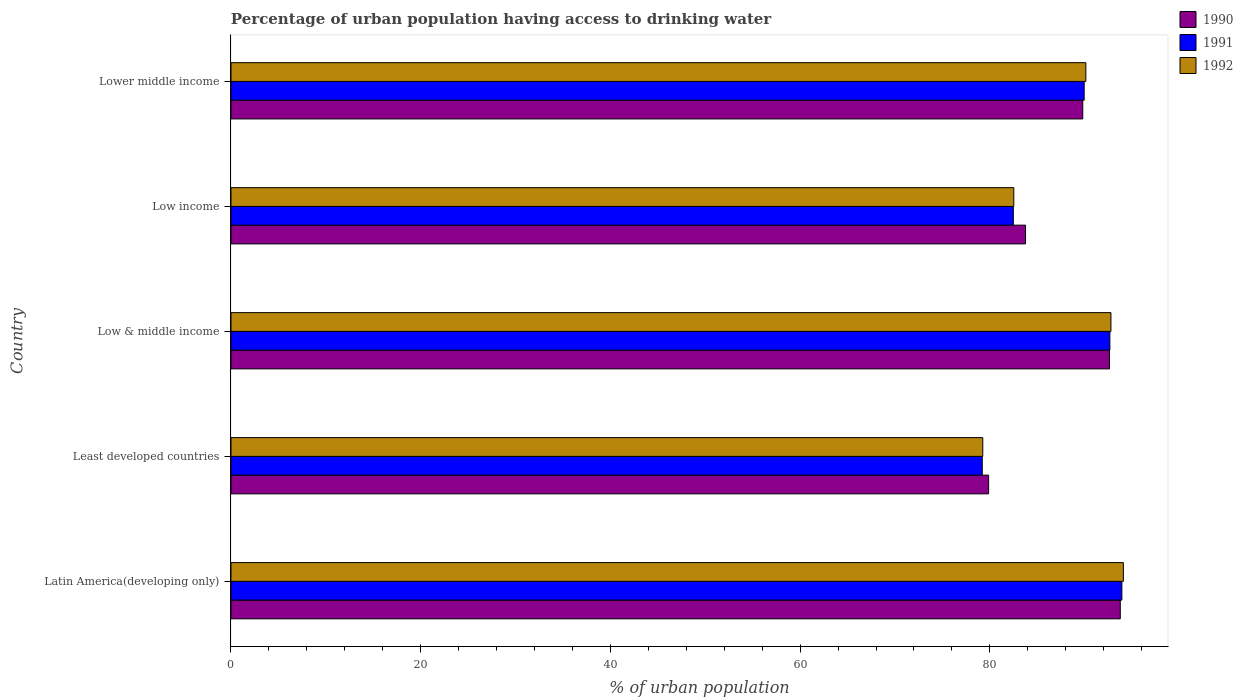How many different coloured bars are there?
Keep it short and to the point. 3. Are the number of bars per tick equal to the number of legend labels?
Ensure brevity in your answer.  Yes. What is the label of the 1st group of bars from the top?
Give a very brief answer. Lower middle income. What is the percentage of urban population having access to drinking water in 1992 in Low & middle income?
Make the answer very short. 92.76. Across all countries, what is the maximum percentage of urban population having access to drinking water in 1990?
Give a very brief answer. 93.75. Across all countries, what is the minimum percentage of urban population having access to drinking water in 1991?
Your answer should be very brief. 79.2. In which country was the percentage of urban population having access to drinking water in 1991 maximum?
Your answer should be compact. Latin America(developing only). In which country was the percentage of urban population having access to drinking water in 1991 minimum?
Make the answer very short. Least developed countries. What is the total percentage of urban population having access to drinking water in 1992 in the graph?
Keep it short and to the point. 438.73. What is the difference between the percentage of urban population having access to drinking water in 1990 in Latin America(developing only) and that in Low income?
Give a very brief answer. 9.99. What is the difference between the percentage of urban population having access to drinking water in 1991 in Latin America(developing only) and the percentage of urban population having access to drinking water in 1990 in Least developed countries?
Keep it short and to the point. 14.05. What is the average percentage of urban population having access to drinking water in 1991 per country?
Your response must be concise. 87.64. What is the difference between the percentage of urban population having access to drinking water in 1992 and percentage of urban population having access to drinking water in 1990 in Least developed countries?
Provide a short and direct response. -0.62. What is the ratio of the percentage of urban population having access to drinking water in 1991 in Latin America(developing only) to that in Low & middle income?
Provide a short and direct response. 1.01. Is the percentage of urban population having access to drinking water in 1991 in Least developed countries less than that in Low & middle income?
Provide a short and direct response. Yes. Is the difference between the percentage of urban population having access to drinking water in 1992 in Low income and Lower middle income greater than the difference between the percentage of urban population having access to drinking water in 1990 in Low income and Lower middle income?
Your response must be concise. No. What is the difference between the highest and the second highest percentage of urban population having access to drinking water in 1992?
Your answer should be compact. 1.31. What is the difference between the highest and the lowest percentage of urban population having access to drinking water in 1991?
Ensure brevity in your answer.  14.72. In how many countries, is the percentage of urban population having access to drinking water in 1991 greater than the average percentage of urban population having access to drinking water in 1991 taken over all countries?
Provide a short and direct response. 3. Is the sum of the percentage of urban population having access to drinking water in 1991 in Least developed countries and Low income greater than the maximum percentage of urban population having access to drinking water in 1992 across all countries?
Keep it short and to the point. Yes. Is it the case that in every country, the sum of the percentage of urban population having access to drinking water in 1991 and percentage of urban population having access to drinking water in 1992 is greater than the percentage of urban population having access to drinking water in 1990?
Your response must be concise. Yes. Are all the bars in the graph horizontal?
Your response must be concise. Yes. How many countries are there in the graph?
Make the answer very short. 5. What is the difference between two consecutive major ticks on the X-axis?
Provide a succinct answer. 20. Does the graph contain any zero values?
Your answer should be very brief. No. Does the graph contain grids?
Keep it short and to the point. No. What is the title of the graph?
Your response must be concise. Percentage of urban population having access to drinking water. Does "2010" appear as one of the legend labels in the graph?
Give a very brief answer. No. What is the label or title of the X-axis?
Keep it short and to the point. % of urban population. What is the label or title of the Y-axis?
Offer a terse response. Country. What is the % of urban population in 1990 in Latin America(developing only)?
Give a very brief answer. 93.75. What is the % of urban population in 1991 in Latin America(developing only)?
Provide a succinct answer. 93.92. What is the % of urban population in 1992 in Latin America(developing only)?
Your response must be concise. 94.07. What is the % of urban population of 1990 in Least developed countries?
Your answer should be compact. 79.87. What is the % of urban population of 1991 in Least developed countries?
Keep it short and to the point. 79.2. What is the % of urban population in 1992 in Least developed countries?
Your response must be concise. 79.25. What is the % of urban population of 1990 in Low & middle income?
Your answer should be compact. 92.61. What is the % of urban population in 1991 in Low & middle income?
Your answer should be very brief. 92.65. What is the % of urban population of 1992 in Low & middle income?
Give a very brief answer. 92.76. What is the % of urban population in 1990 in Low income?
Make the answer very short. 83.76. What is the % of urban population of 1991 in Low income?
Keep it short and to the point. 82.47. What is the % of urban population in 1992 in Low income?
Keep it short and to the point. 82.52. What is the % of urban population in 1990 in Lower middle income?
Your answer should be very brief. 89.79. What is the % of urban population of 1991 in Lower middle income?
Provide a short and direct response. 89.94. What is the % of urban population of 1992 in Lower middle income?
Ensure brevity in your answer.  90.12. Across all countries, what is the maximum % of urban population of 1990?
Provide a short and direct response. 93.75. Across all countries, what is the maximum % of urban population in 1991?
Your answer should be compact. 93.92. Across all countries, what is the maximum % of urban population in 1992?
Your response must be concise. 94.07. Across all countries, what is the minimum % of urban population of 1990?
Keep it short and to the point. 79.87. Across all countries, what is the minimum % of urban population in 1991?
Keep it short and to the point. 79.2. Across all countries, what is the minimum % of urban population in 1992?
Offer a terse response. 79.25. What is the total % of urban population in 1990 in the graph?
Provide a short and direct response. 439.78. What is the total % of urban population in 1991 in the graph?
Make the answer very short. 438.18. What is the total % of urban population in 1992 in the graph?
Give a very brief answer. 438.73. What is the difference between the % of urban population of 1990 in Latin America(developing only) and that in Least developed countries?
Your answer should be compact. 13.88. What is the difference between the % of urban population of 1991 in Latin America(developing only) and that in Least developed countries?
Keep it short and to the point. 14.72. What is the difference between the % of urban population of 1992 in Latin America(developing only) and that in Least developed countries?
Provide a short and direct response. 14.82. What is the difference between the % of urban population in 1990 in Latin America(developing only) and that in Low & middle income?
Provide a short and direct response. 1.14. What is the difference between the % of urban population in 1991 in Latin America(developing only) and that in Low & middle income?
Give a very brief answer. 1.27. What is the difference between the % of urban population of 1992 in Latin America(developing only) and that in Low & middle income?
Provide a short and direct response. 1.31. What is the difference between the % of urban population in 1990 in Latin America(developing only) and that in Low income?
Provide a short and direct response. 9.99. What is the difference between the % of urban population in 1991 in Latin America(developing only) and that in Low income?
Provide a short and direct response. 11.44. What is the difference between the % of urban population of 1992 in Latin America(developing only) and that in Low income?
Provide a short and direct response. 11.55. What is the difference between the % of urban population of 1990 in Latin America(developing only) and that in Lower middle income?
Provide a short and direct response. 3.95. What is the difference between the % of urban population of 1991 in Latin America(developing only) and that in Lower middle income?
Offer a very short reply. 3.97. What is the difference between the % of urban population in 1992 in Latin America(developing only) and that in Lower middle income?
Your answer should be compact. 3.96. What is the difference between the % of urban population of 1990 in Least developed countries and that in Low & middle income?
Offer a terse response. -12.74. What is the difference between the % of urban population in 1991 in Least developed countries and that in Low & middle income?
Offer a terse response. -13.45. What is the difference between the % of urban population of 1992 in Least developed countries and that in Low & middle income?
Keep it short and to the point. -13.51. What is the difference between the % of urban population of 1990 in Least developed countries and that in Low income?
Your answer should be very brief. -3.89. What is the difference between the % of urban population in 1991 in Least developed countries and that in Low income?
Your answer should be very brief. -3.28. What is the difference between the % of urban population in 1992 in Least developed countries and that in Low income?
Keep it short and to the point. -3.27. What is the difference between the % of urban population in 1990 in Least developed countries and that in Lower middle income?
Your answer should be very brief. -9.92. What is the difference between the % of urban population in 1991 in Least developed countries and that in Lower middle income?
Ensure brevity in your answer.  -10.74. What is the difference between the % of urban population in 1992 in Least developed countries and that in Lower middle income?
Offer a very short reply. -10.87. What is the difference between the % of urban population in 1990 in Low & middle income and that in Low income?
Provide a succinct answer. 8.85. What is the difference between the % of urban population in 1991 in Low & middle income and that in Low income?
Your answer should be compact. 10.18. What is the difference between the % of urban population of 1992 in Low & middle income and that in Low income?
Ensure brevity in your answer.  10.24. What is the difference between the % of urban population of 1990 in Low & middle income and that in Lower middle income?
Your response must be concise. 2.82. What is the difference between the % of urban population in 1991 in Low & middle income and that in Lower middle income?
Provide a short and direct response. 2.71. What is the difference between the % of urban population in 1992 in Low & middle income and that in Lower middle income?
Your response must be concise. 2.64. What is the difference between the % of urban population in 1990 in Low income and that in Lower middle income?
Your answer should be compact. -6.03. What is the difference between the % of urban population of 1991 in Low income and that in Lower middle income?
Offer a very short reply. -7.47. What is the difference between the % of urban population in 1992 in Low income and that in Lower middle income?
Keep it short and to the point. -7.6. What is the difference between the % of urban population of 1990 in Latin America(developing only) and the % of urban population of 1991 in Least developed countries?
Your answer should be compact. 14.55. What is the difference between the % of urban population in 1990 in Latin America(developing only) and the % of urban population in 1992 in Least developed countries?
Provide a succinct answer. 14.5. What is the difference between the % of urban population in 1991 in Latin America(developing only) and the % of urban population in 1992 in Least developed countries?
Your answer should be very brief. 14.66. What is the difference between the % of urban population in 1990 in Latin America(developing only) and the % of urban population in 1991 in Low & middle income?
Keep it short and to the point. 1.1. What is the difference between the % of urban population of 1990 in Latin America(developing only) and the % of urban population of 1992 in Low & middle income?
Offer a very short reply. 0.99. What is the difference between the % of urban population in 1991 in Latin America(developing only) and the % of urban population in 1992 in Low & middle income?
Ensure brevity in your answer.  1.15. What is the difference between the % of urban population in 1990 in Latin America(developing only) and the % of urban population in 1991 in Low income?
Ensure brevity in your answer.  11.27. What is the difference between the % of urban population in 1990 in Latin America(developing only) and the % of urban population in 1992 in Low income?
Offer a very short reply. 11.23. What is the difference between the % of urban population of 1991 in Latin America(developing only) and the % of urban population of 1992 in Low income?
Provide a succinct answer. 11.39. What is the difference between the % of urban population of 1990 in Latin America(developing only) and the % of urban population of 1991 in Lower middle income?
Give a very brief answer. 3.81. What is the difference between the % of urban population of 1990 in Latin America(developing only) and the % of urban population of 1992 in Lower middle income?
Provide a succinct answer. 3.63. What is the difference between the % of urban population in 1991 in Latin America(developing only) and the % of urban population in 1992 in Lower middle income?
Provide a succinct answer. 3.8. What is the difference between the % of urban population of 1990 in Least developed countries and the % of urban population of 1991 in Low & middle income?
Your response must be concise. -12.78. What is the difference between the % of urban population in 1990 in Least developed countries and the % of urban population in 1992 in Low & middle income?
Give a very brief answer. -12.89. What is the difference between the % of urban population of 1991 in Least developed countries and the % of urban population of 1992 in Low & middle income?
Provide a short and direct response. -13.56. What is the difference between the % of urban population of 1990 in Least developed countries and the % of urban population of 1991 in Low income?
Your response must be concise. -2.6. What is the difference between the % of urban population of 1990 in Least developed countries and the % of urban population of 1992 in Low income?
Your answer should be compact. -2.65. What is the difference between the % of urban population of 1991 in Least developed countries and the % of urban population of 1992 in Low income?
Your answer should be very brief. -3.32. What is the difference between the % of urban population of 1990 in Least developed countries and the % of urban population of 1991 in Lower middle income?
Your response must be concise. -10.07. What is the difference between the % of urban population in 1990 in Least developed countries and the % of urban population in 1992 in Lower middle income?
Give a very brief answer. -10.25. What is the difference between the % of urban population in 1991 in Least developed countries and the % of urban population in 1992 in Lower middle income?
Your response must be concise. -10.92. What is the difference between the % of urban population of 1990 in Low & middle income and the % of urban population of 1991 in Low income?
Your response must be concise. 10.14. What is the difference between the % of urban population of 1990 in Low & middle income and the % of urban population of 1992 in Low income?
Provide a short and direct response. 10.09. What is the difference between the % of urban population in 1991 in Low & middle income and the % of urban population in 1992 in Low income?
Offer a very short reply. 10.13. What is the difference between the % of urban population in 1990 in Low & middle income and the % of urban population in 1991 in Lower middle income?
Your answer should be very brief. 2.67. What is the difference between the % of urban population in 1990 in Low & middle income and the % of urban population in 1992 in Lower middle income?
Offer a terse response. 2.49. What is the difference between the % of urban population in 1991 in Low & middle income and the % of urban population in 1992 in Lower middle income?
Keep it short and to the point. 2.53. What is the difference between the % of urban population of 1990 in Low income and the % of urban population of 1991 in Lower middle income?
Provide a succinct answer. -6.18. What is the difference between the % of urban population in 1990 in Low income and the % of urban population in 1992 in Lower middle income?
Offer a terse response. -6.36. What is the difference between the % of urban population in 1991 in Low income and the % of urban population in 1992 in Lower middle income?
Your answer should be very brief. -7.64. What is the average % of urban population of 1990 per country?
Provide a succinct answer. 87.96. What is the average % of urban population in 1991 per country?
Keep it short and to the point. 87.64. What is the average % of urban population of 1992 per country?
Make the answer very short. 87.75. What is the difference between the % of urban population in 1990 and % of urban population in 1991 in Latin America(developing only)?
Keep it short and to the point. -0.17. What is the difference between the % of urban population of 1990 and % of urban population of 1992 in Latin America(developing only)?
Ensure brevity in your answer.  -0.33. What is the difference between the % of urban population in 1991 and % of urban population in 1992 in Latin America(developing only)?
Ensure brevity in your answer.  -0.16. What is the difference between the % of urban population of 1990 and % of urban population of 1991 in Least developed countries?
Provide a succinct answer. 0.67. What is the difference between the % of urban population of 1990 and % of urban population of 1992 in Least developed countries?
Make the answer very short. 0.62. What is the difference between the % of urban population in 1991 and % of urban population in 1992 in Least developed countries?
Give a very brief answer. -0.05. What is the difference between the % of urban population in 1990 and % of urban population in 1991 in Low & middle income?
Provide a short and direct response. -0.04. What is the difference between the % of urban population in 1990 and % of urban population in 1992 in Low & middle income?
Your answer should be compact. -0.15. What is the difference between the % of urban population of 1991 and % of urban population of 1992 in Low & middle income?
Your answer should be very brief. -0.11. What is the difference between the % of urban population of 1990 and % of urban population of 1991 in Low income?
Your answer should be compact. 1.29. What is the difference between the % of urban population in 1990 and % of urban population in 1992 in Low income?
Ensure brevity in your answer.  1.24. What is the difference between the % of urban population in 1991 and % of urban population in 1992 in Low income?
Your answer should be very brief. -0.05. What is the difference between the % of urban population in 1990 and % of urban population in 1991 in Lower middle income?
Your answer should be very brief. -0.15. What is the difference between the % of urban population of 1990 and % of urban population of 1992 in Lower middle income?
Offer a terse response. -0.33. What is the difference between the % of urban population in 1991 and % of urban population in 1992 in Lower middle income?
Provide a short and direct response. -0.18. What is the ratio of the % of urban population of 1990 in Latin America(developing only) to that in Least developed countries?
Keep it short and to the point. 1.17. What is the ratio of the % of urban population in 1991 in Latin America(developing only) to that in Least developed countries?
Keep it short and to the point. 1.19. What is the ratio of the % of urban population in 1992 in Latin America(developing only) to that in Least developed countries?
Offer a terse response. 1.19. What is the ratio of the % of urban population of 1990 in Latin America(developing only) to that in Low & middle income?
Your answer should be compact. 1.01. What is the ratio of the % of urban population in 1991 in Latin America(developing only) to that in Low & middle income?
Your response must be concise. 1.01. What is the ratio of the % of urban population in 1992 in Latin America(developing only) to that in Low & middle income?
Offer a terse response. 1.01. What is the ratio of the % of urban population of 1990 in Latin America(developing only) to that in Low income?
Provide a succinct answer. 1.12. What is the ratio of the % of urban population of 1991 in Latin America(developing only) to that in Low income?
Offer a terse response. 1.14. What is the ratio of the % of urban population of 1992 in Latin America(developing only) to that in Low income?
Give a very brief answer. 1.14. What is the ratio of the % of urban population of 1990 in Latin America(developing only) to that in Lower middle income?
Offer a terse response. 1.04. What is the ratio of the % of urban population of 1991 in Latin America(developing only) to that in Lower middle income?
Your answer should be compact. 1.04. What is the ratio of the % of urban population in 1992 in Latin America(developing only) to that in Lower middle income?
Your answer should be compact. 1.04. What is the ratio of the % of urban population in 1990 in Least developed countries to that in Low & middle income?
Your response must be concise. 0.86. What is the ratio of the % of urban population of 1991 in Least developed countries to that in Low & middle income?
Your answer should be very brief. 0.85. What is the ratio of the % of urban population of 1992 in Least developed countries to that in Low & middle income?
Your response must be concise. 0.85. What is the ratio of the % of urban population in 1990 in Least developed countries to that in Low income?
Keep it short and to the point. 0.95. What is the ratio of the % of urban population of 1991 in Least developed countries to that in Low income?
Keep it short and to the point. 0.96. What is the ratio of the % of urban population in 1992 in Least developed countries to that in Low income?
Make the answer very short. 0.96. What is the ratio of the % of urban population in 1990 in Least developed countries to that in Lower middle income?
Keep it short and to the point. 0.89. What is the ratio of the % of urban population in 1991 in Least developed countries to that in Lower middle income?
Ensure brevity in your answer.  0.88. What is the ratio of the % of urban population in 1992 in Least developed countries to that in Lower middle income?
Offer a very short reply. 0.88. What is the ratio of the % of urban population in 1990 in Low & middle income to that in Low income?
Provide a succinct answer. 1.11. What is the ratio of the % of urban population in 1991 in Low & middle income to that in Low income?
Give a very brief answer. 1.12. What is the ratio of the % of urban population of 1992 in Low & middle income to that in Low income?
Provide a short and direct response. 1.12. What is the ratio of the % of urban population in 1990 in Low & middle income to that in Lower middle income?
Your response must be concise. 1.03. What is the ratio of the % of urban population of 1991 in Low & middle income to that in Lower middle income?
Ensure brevity in your answer.  1.03. What is the ratio of the % of urban population of 1992 in Low & middle income to that in Lower middle income?
Keep it short and to the point. 1.03. What is the ratio of the % of urban population of 1990 in Low income to that in Lower middle income?
Provide a succinct answer. 0.93. What is the ratio of the % of urban population in 1991 in Low income to that in Lower middle income?
Make the answer very short. 0.92. What is the ratio of the % of urban population in 1992 in Low income to that in Lower middle income?
Offer a very short reply. 0.92. What is the difference between the highest and the second highest % of urban population in 1990?
Keep it short and to the point. 1.14. What is the difference between the highest and the second highest % of urban population of 1991?
Offer a very short reply. 1.27. What is the difference between the highest and the second highest % of urban population in 1992?
Keep it short and to the point. 1.31. What is the difference between the highest and the lowest % of urban population of 1990?
Your answer should be compact. 13.88. What is the difference between the highest and the lowest % of urban population in 1991?
Offer a terse response. 14.72. What is the difference between the highest and the lowest % of urban population of 1992?
Your answer should be compact. 14.82. 